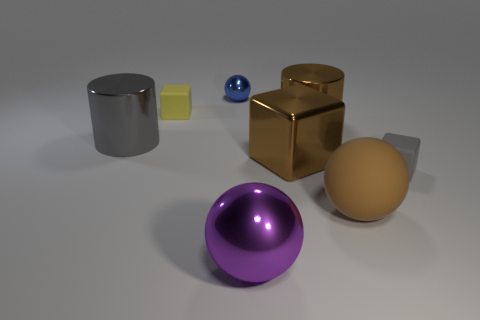Could you describe any patterns of light and shadow in the image? Certainly. The image has a soft overhead lighting that casts gentle shadows directly under each object. The shadows are soft-edged, indicating a diffused light source. The reflective surfaces of the metallic and glass objects capture highlights on the sides facing the light source, further emphasizing their reflective qualities. These patterns of light and shadow create a sense of depth and three-dimensionality in the image. 